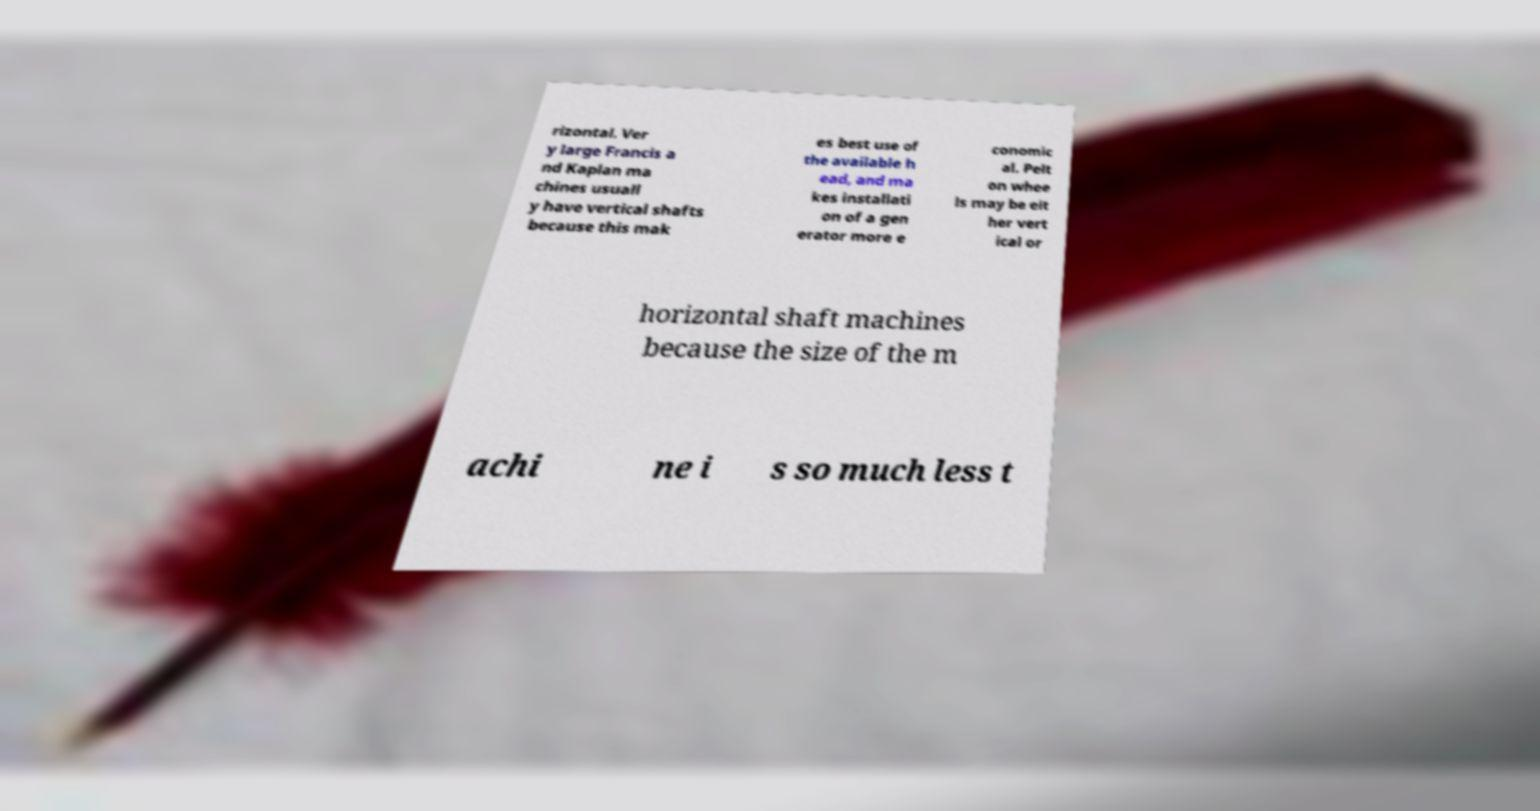Please read and relay the text visible in this image. What does it say? rizontal. Ver y large Francis a nd Kaplan ma chines usuall y have vertical shafts because this mak es best use of the available h ead, and ma kes installati on of a gen erator more e conomic al. Pelt on whee ls may be eit her vert ical or horizontal shaft machines because the size of the m achi ne i s so much less t 